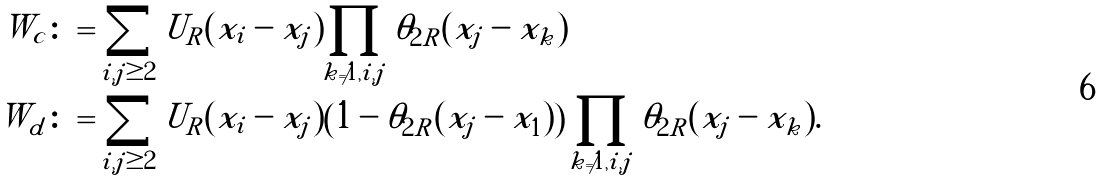Convert formula to latex. <formula><loc_0><loc_0><loc_500><loc_500>W _ { c } & \colon = \sum _ { i , j \geq 2 } U _ { R } ( x _ { i } - x _ { j } ) \prod _ { k \ne 1 , i , j } \theta _ { 2 R } ( x _ { j } - x _ { k } ) \\ W _ { d } & \colon = \sum _ { i , j \geq 2 } U _ { R } ( x _ { i } - x _ { j } ) \left ( 1 - \theta _ { 2 R } ( x _ { j } - x _ { 1 } ) \right ) \prod _ { k \ne 1 , i , j } \theta _ { 2 R } ( x _ { j } - x _ { k } ) .</formula> 